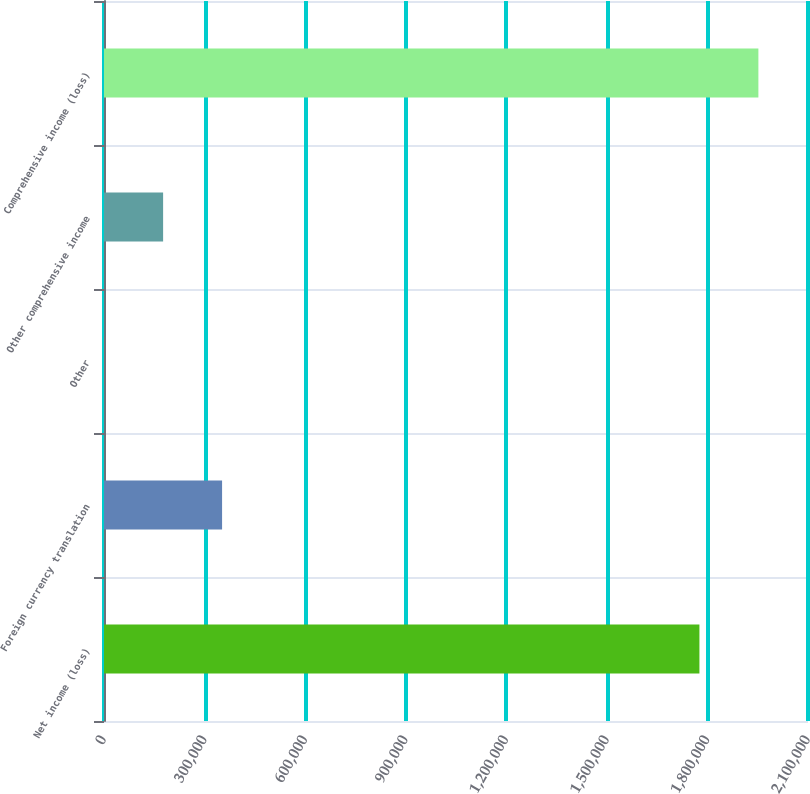<chart> <loc_0><loc_0><loc_500><loc_500><bar_chart><fcel>Net income (loss)<fcel>Foreign currency translation<fcel>Other<fcel>Other comprehensive income<fcel>Comprehensive income (loss)<nl><fcel>1.77613e+06<fcel>352229<fcel>445<fcel>176337<fcel>1.95202e+06<nl></chart> 